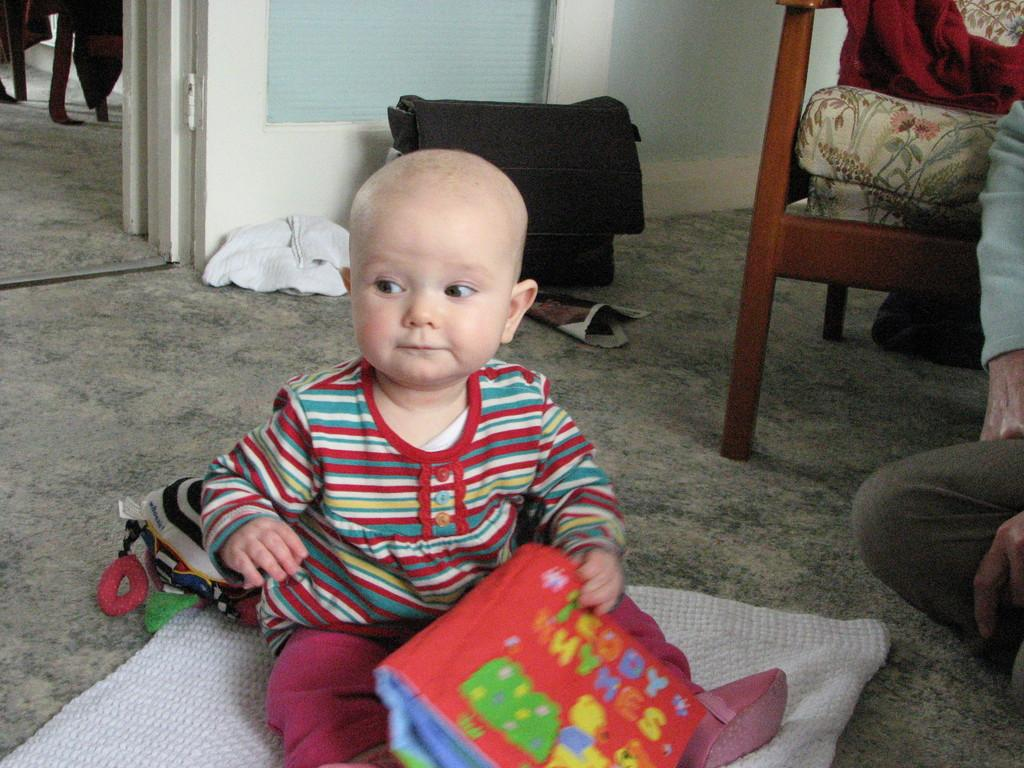What is the kid in the image doing? The kid is sitting on the floor and playing with a bag. What can be seen in the background of the image? There is a door, a wall, a chair, and a person in the background. Are there any other bags visible in the image? Yes, there is another bag in the background. What type of apparel is the stranger wearing in the image? There is no stranger present in the image, so it is not possible to determine what type of apparel they might be wearing. 